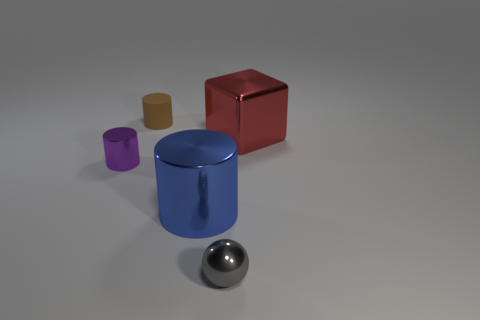Subtract all small brown cylinders. How many cylinders are left? 2 Subtract 1 cubes. How many cubes are left? 0 Add 5 big brown matte things. How many objects exist? 10 Subtract all cubes. How many objects are left? 4 Add 3 brown rubber cylinders. How many brown rubber cylinders are left? 4 Add 4 red cubes. How many red cubes exist? 5 Subtract 0 yellow blocks. How many objects are left? 5 Subtract all cyan blocks. Subtract all green cylinders. How many blocks are left? 1 Subtract all large red balls. Subtract all large shiny objects. How many objects are left? 3 